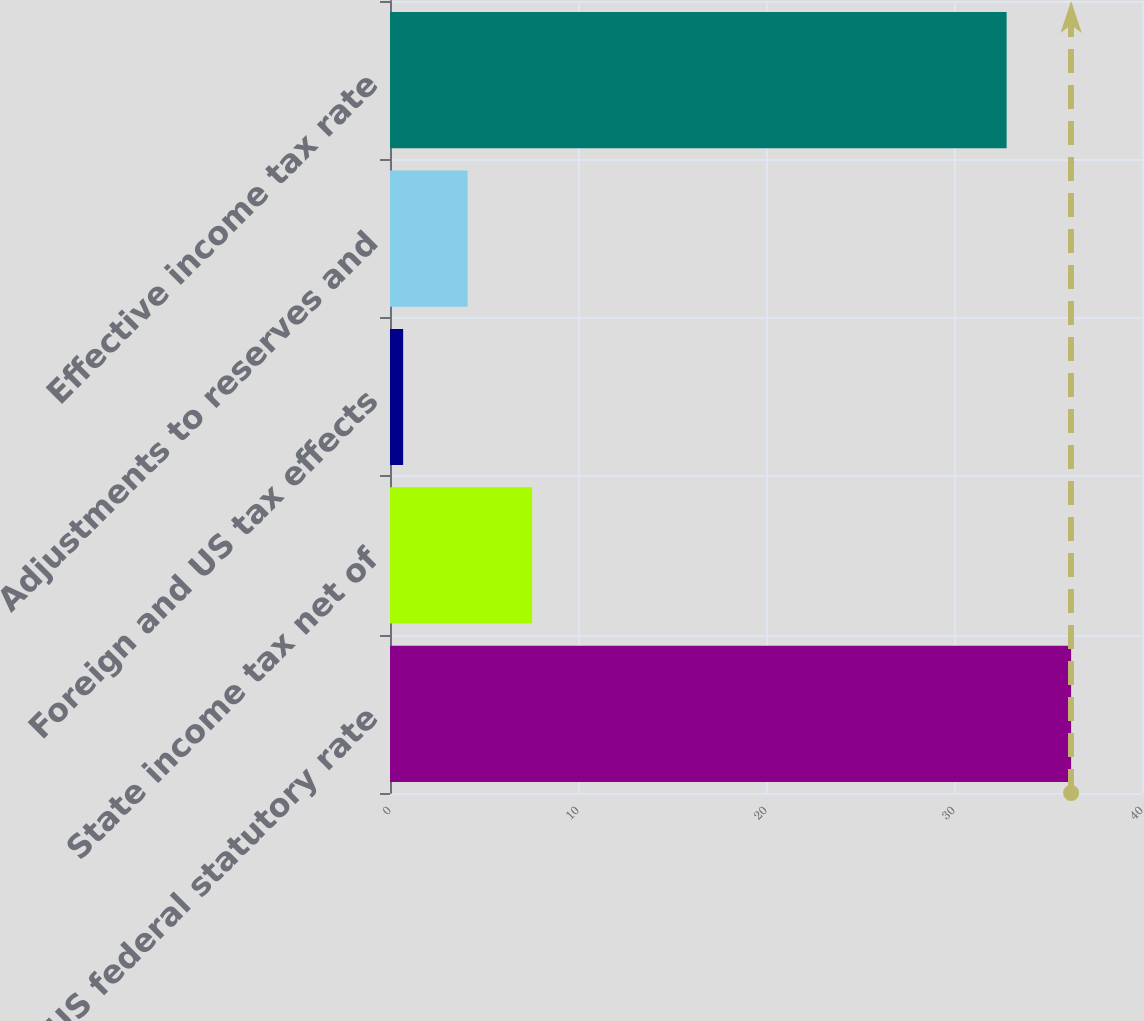Convert chart to OTSL. <chart><loc_0><loc_0><loc_500><loc_500><bar_chart><fcel>US federal statutory rate<fcel>State income tax net of<fcel>Foreign and US tax effects<fcel>Adjustments to reserves and<fcel>Effective income tax rate<nl><fcel>36.23<fcel>7.56<fcel>0.7<fcel>4.13<fcel>32.8<nl></chart> 